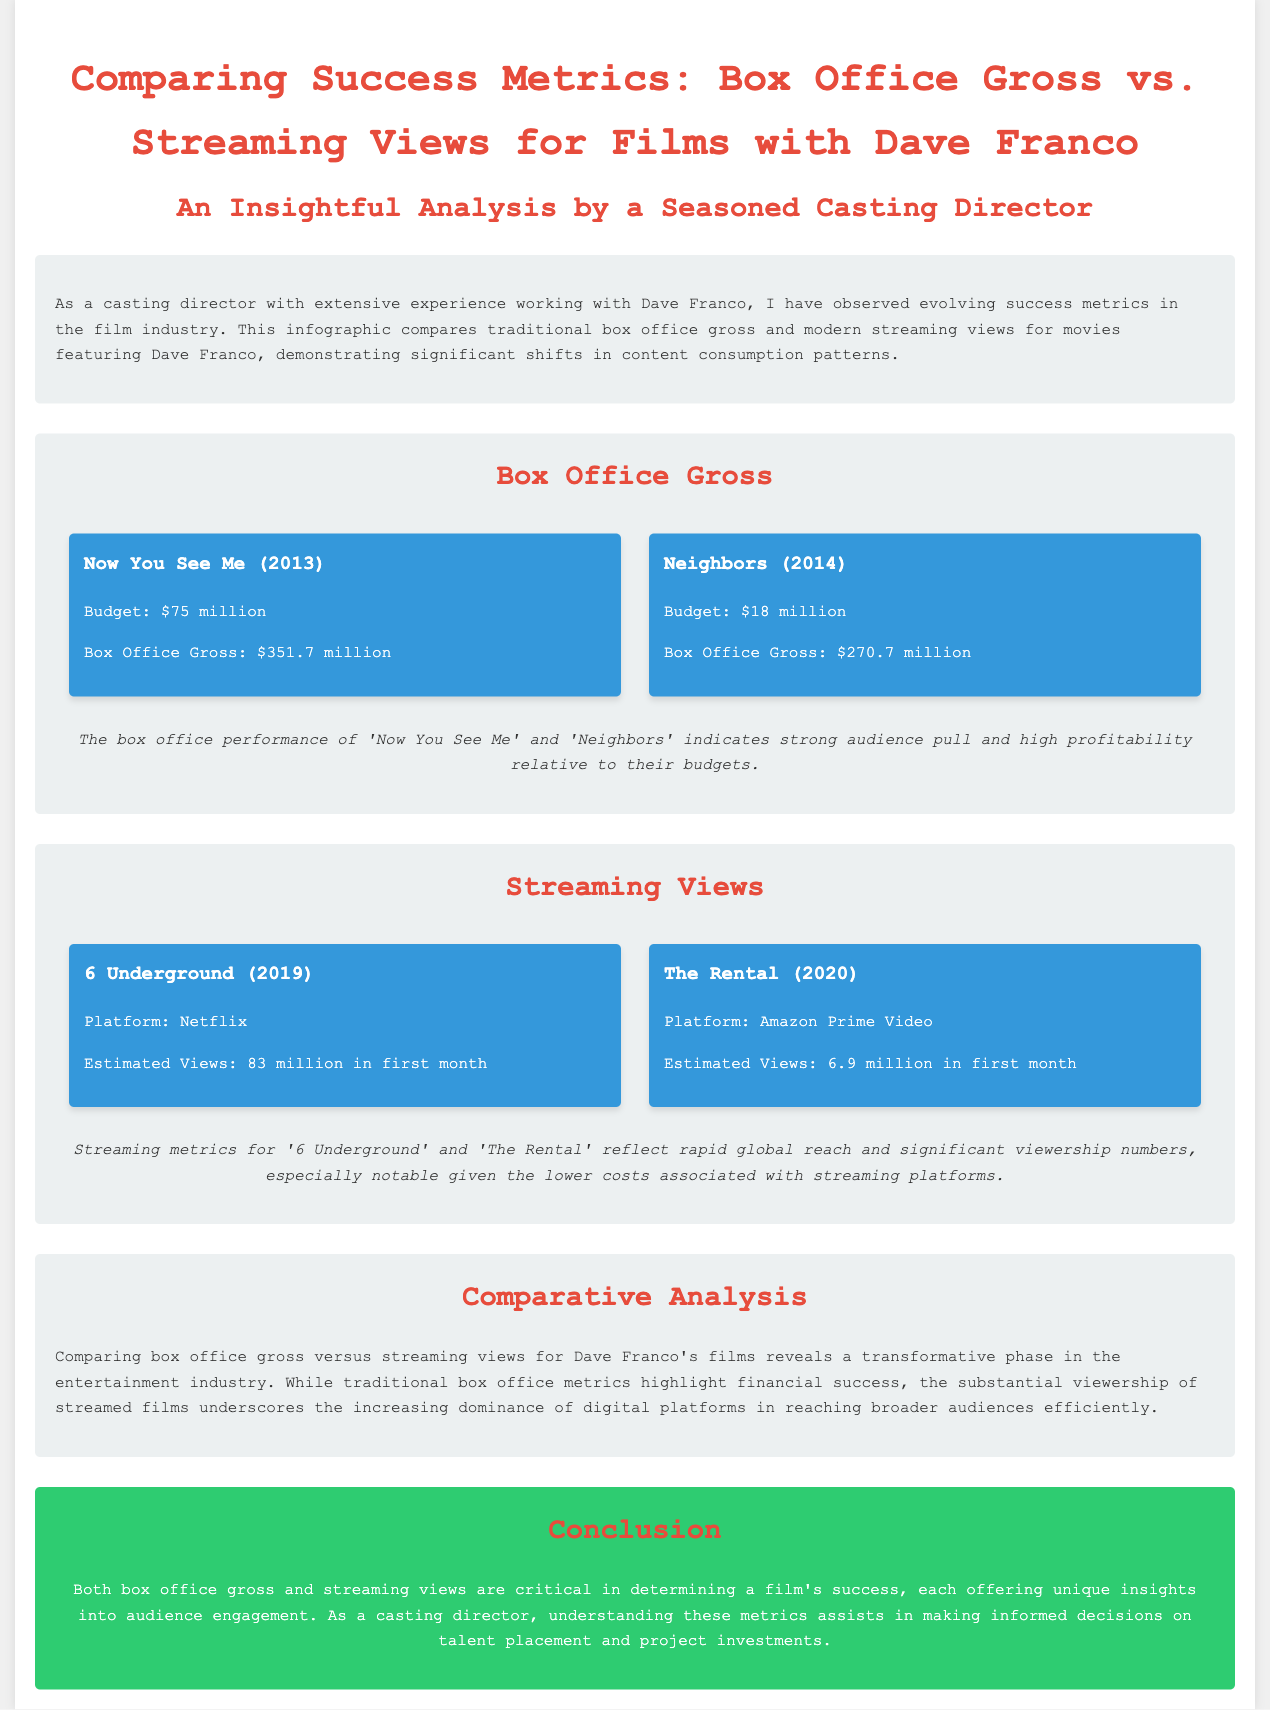What is the box office gross of "Now You See Me"? The box office gross is listed in the document as $351.7 million.
Answer: $351.7 million What platform is "The Rental" available on? The document specifies that "The Rental" is available on Amazon Prime Video.
Answer: Amazon Prime Video What was the budget for "Neighbors"? The budget for "Neighbors" is detailed in the document as $18 million.
Answer: $18 million What were the estimated views for "6 Underground" in the first month? The document states that "6 Underground" had estimated views of 83 million in the first month.
Answer: 83 million Which film had a higher box office gross, "Neighbors" or "Now You See Me"? The document compares the box office gross and shows that "Now You See Me" had a higher gross than "Neighbors".
Answer: Now You See Me What does the document indicate about the trend in audience consumption? The document mentions a significant shift in content consumption patterns towards digital platforms.
Answer: Shift towards digital platforms Which film had lower estimated views, "6 Underground" or "The Rental"? The document specifies that "The Rental" had lower estimated views than "6 Underground".
Answer: The Rental What key insights does the document provide for casting directors? The conclusion emphasizes the importance of understanding both box office gross and streaming views for informed decision-making.
Answer: Informed decision-making 